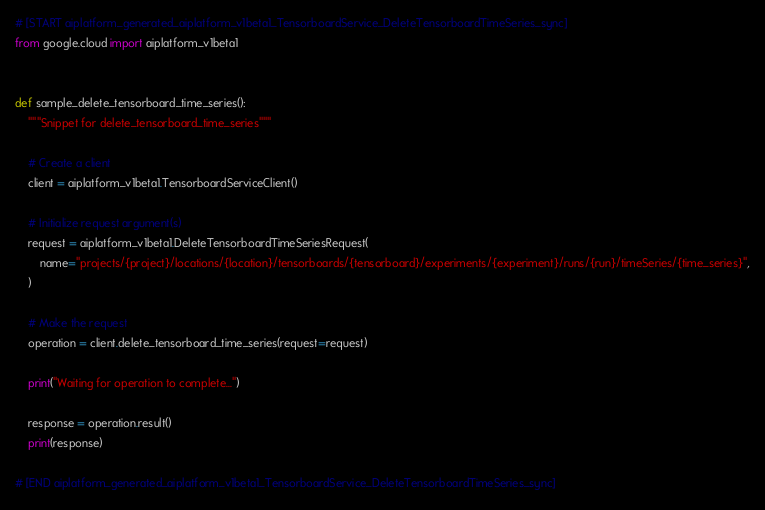Convert code to text. <code><loc_0><loc_0><loc_500><loc_500><_Python_>
# [START aiplatform_generated_aiplatform_v1beta1_TensorboardService_DeleteTensorboardTimeSeries_sync]
from google.cloud import aiplatform_v1beta1


def sample_delete_tensorboard_time_series():
    """Snippet for delete_tensorboard_time_series"""

    # Create a client
    client = aiplatform_v1beta1.TensorboardServiceClient()

    # Initialize request argument(s)
    request = aiplatform_v1beta1.DeleteTensorboardTimeSeriesRequest(
        name="projects/{project}/locations/{location}/tensorboards/{tensorboard}/experiments/{experiment}/runs/{run}/timeSeries/{time_series}",
    )

    # Make the request
    operation = client.delete_tensorboard_time_series(request=request)

    print("Waiting for operation to complete...")

    response = operation.result()
    print(response)

# [END aiplatform_generated_aiplatform_v1beta1_TensorboardService_DeleteTensorboardTimeSeries_sync]
</code> 